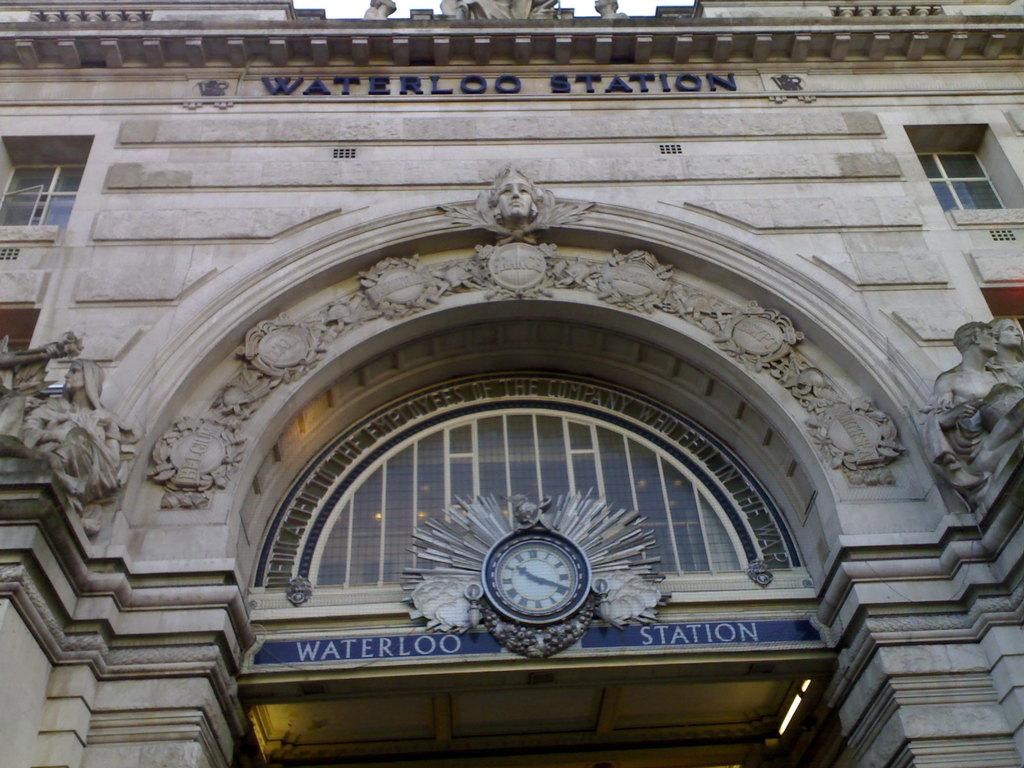Provide a one-sentence caption for the provided image. The entrance to a train station called Waterloo Station. 